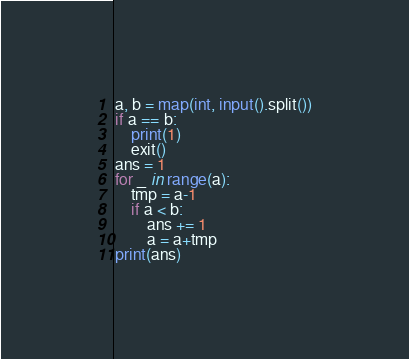<code> <loc_0><loc_0><loc_500><loc_500><_Python_>a, b = map(int, input().split())
if a == b:
    print(1)
    exit()
ans = 1
for _ in range(a):
    tmp = a-1
    if a < b:
        ans += 1
        a = a+tmp
print(ans)</code> 